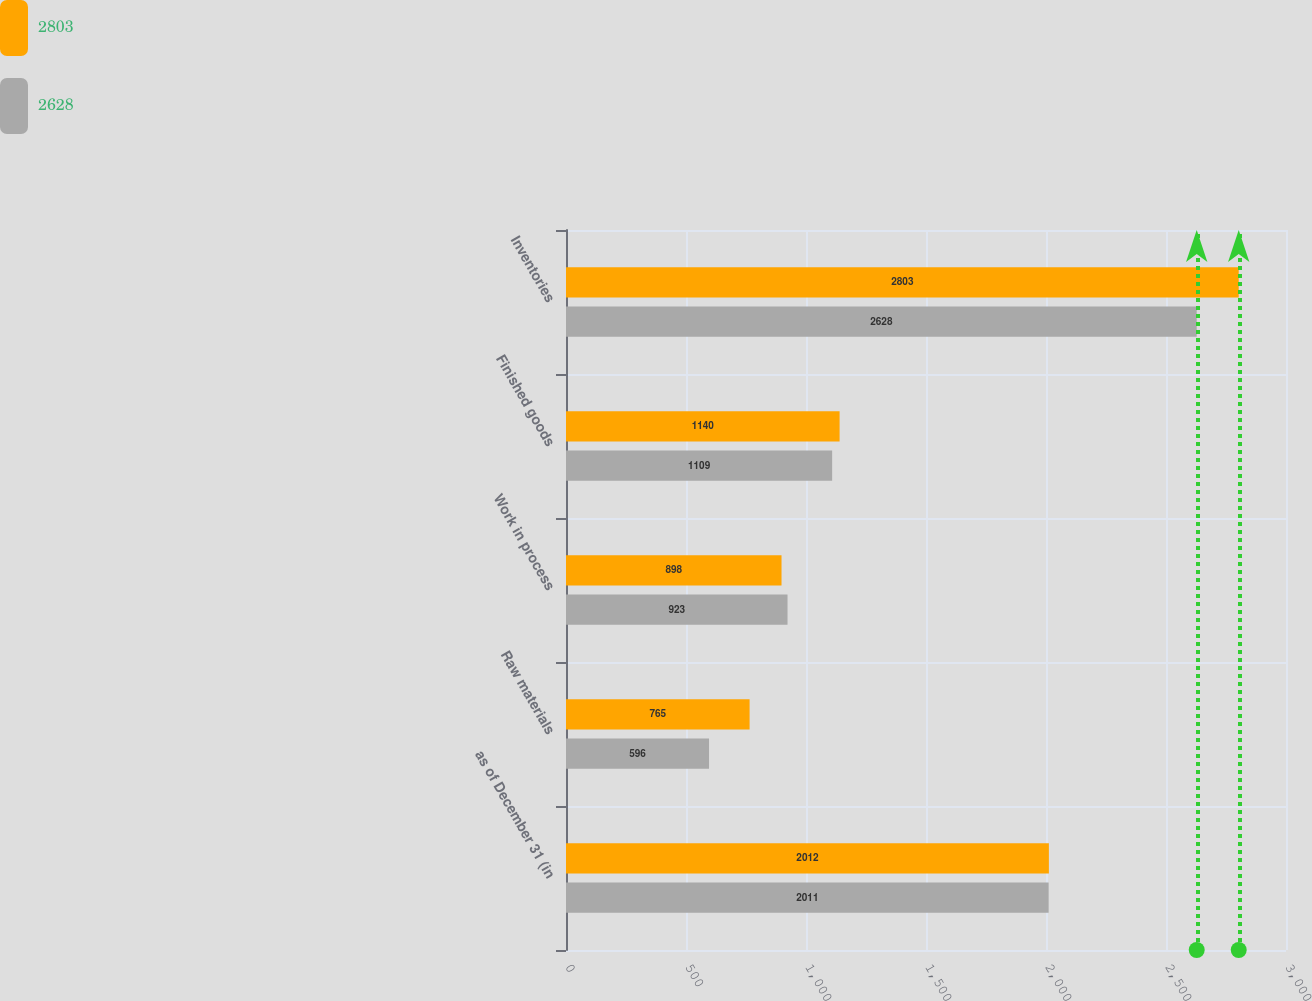Convert chart to OTSL. <chart><loc_0><loc_0><loc_500><loc_500><stacked_bar_chart><ecel><fcel>as of December 31 (in<fcel>Raw materials<fcel>Work in process<fcel>Finished goods<fcel>Inventories<nl><fcel>2803<fcel>2012<fcel>765<fcel>898<fcel>1140<fcel>2803<nl><fcel>2628<fcel>2011<fcel>596<fcel>923<fcel>1109<fcel>2628<nl></chart> 